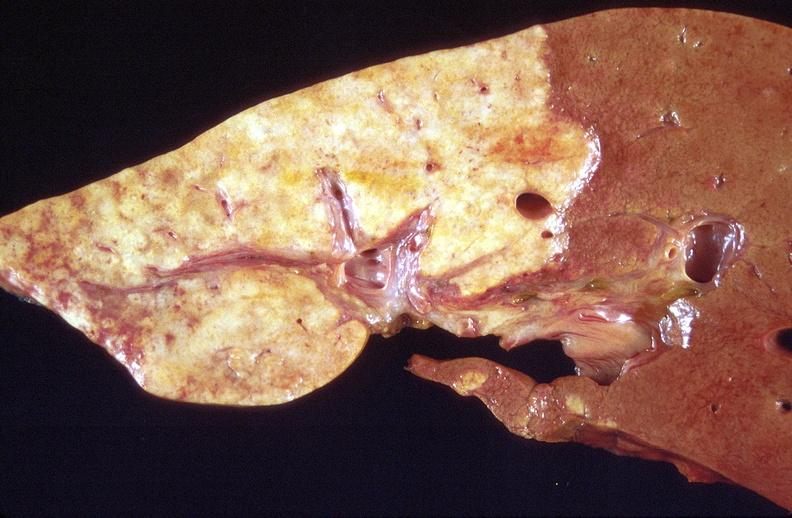what is present?
Answer the question using a single word or phrase. Hepatobiliary 